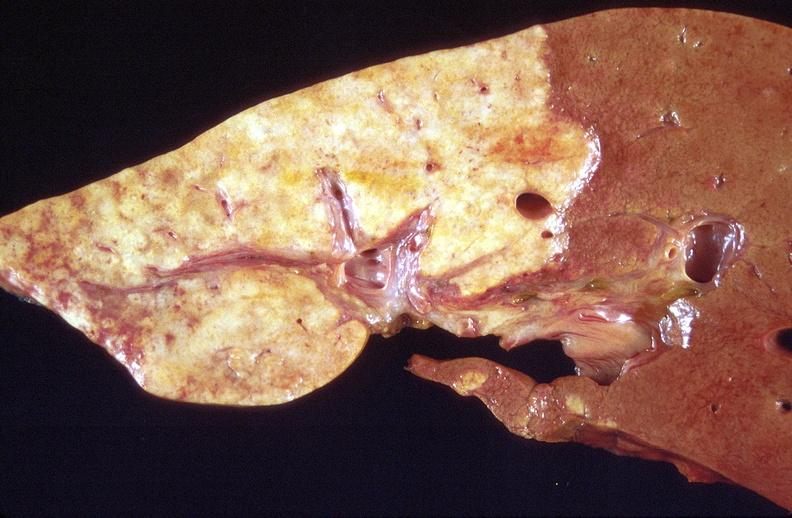what is present?
Answer the question using a single word or phrase. Hepatobiliary 